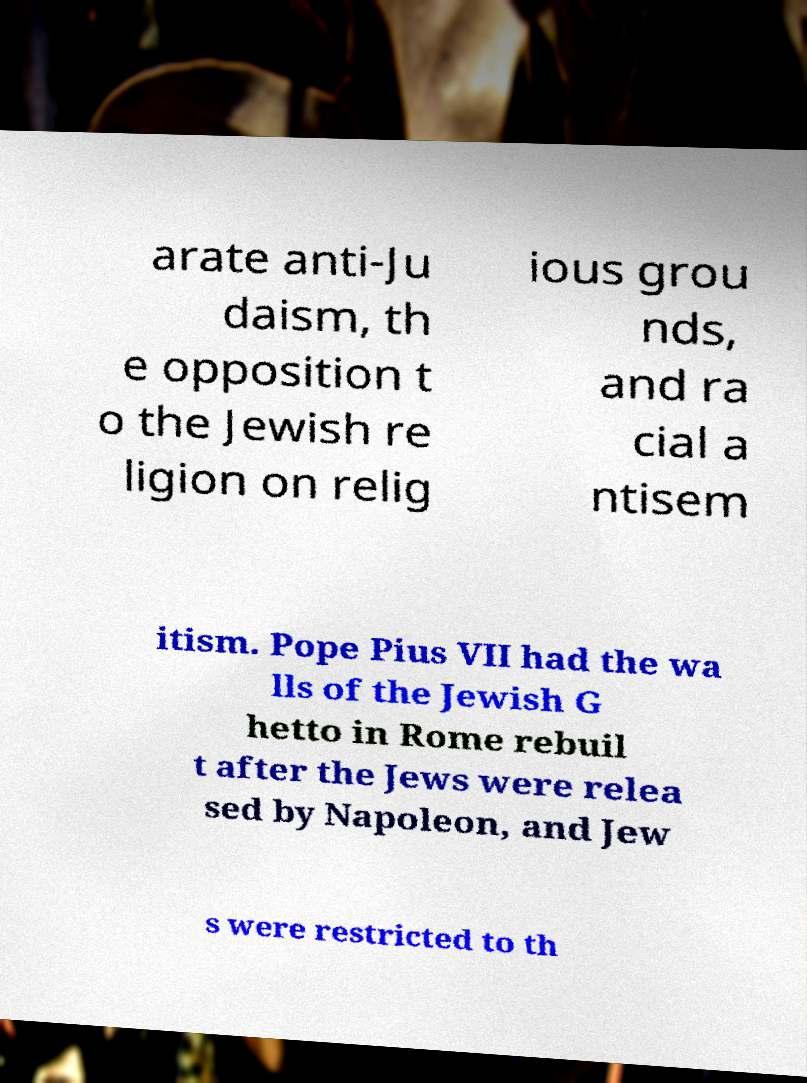I need the written content from this picture converted into text. Can you do that? arate anti-Ju daism, th e opposition t o the Jewish re ligion on relig ious grou nds, and ra cial a ntisem itism. Pope Pius VII had the wa lls of the Jewish G hetto in Rome rebuil t after the Jews were relea sed by Napoleon, and Jew s were restricted to th 